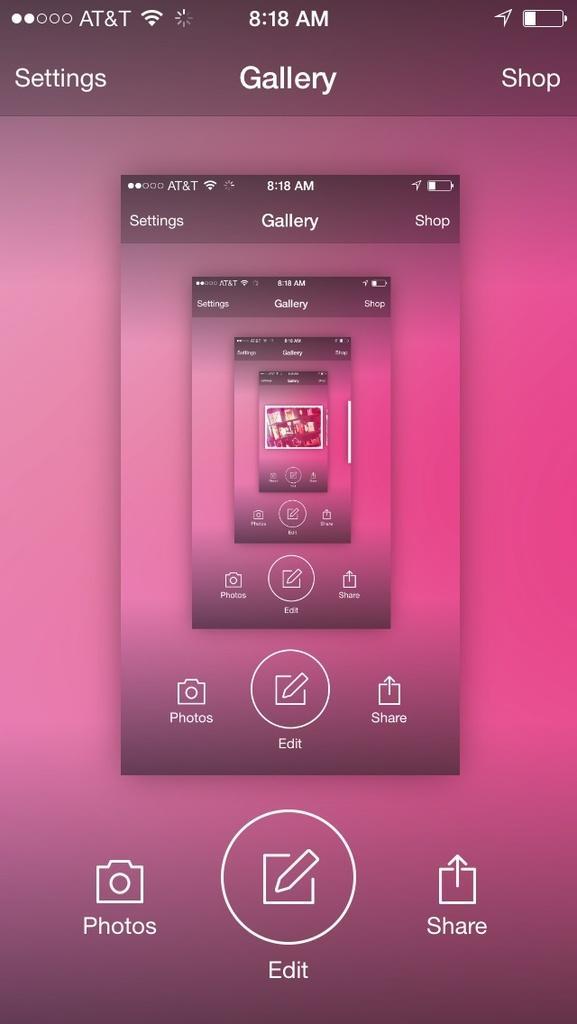Please provide a concise description of this image. This is a pink color screen of a mobile with some icons. 